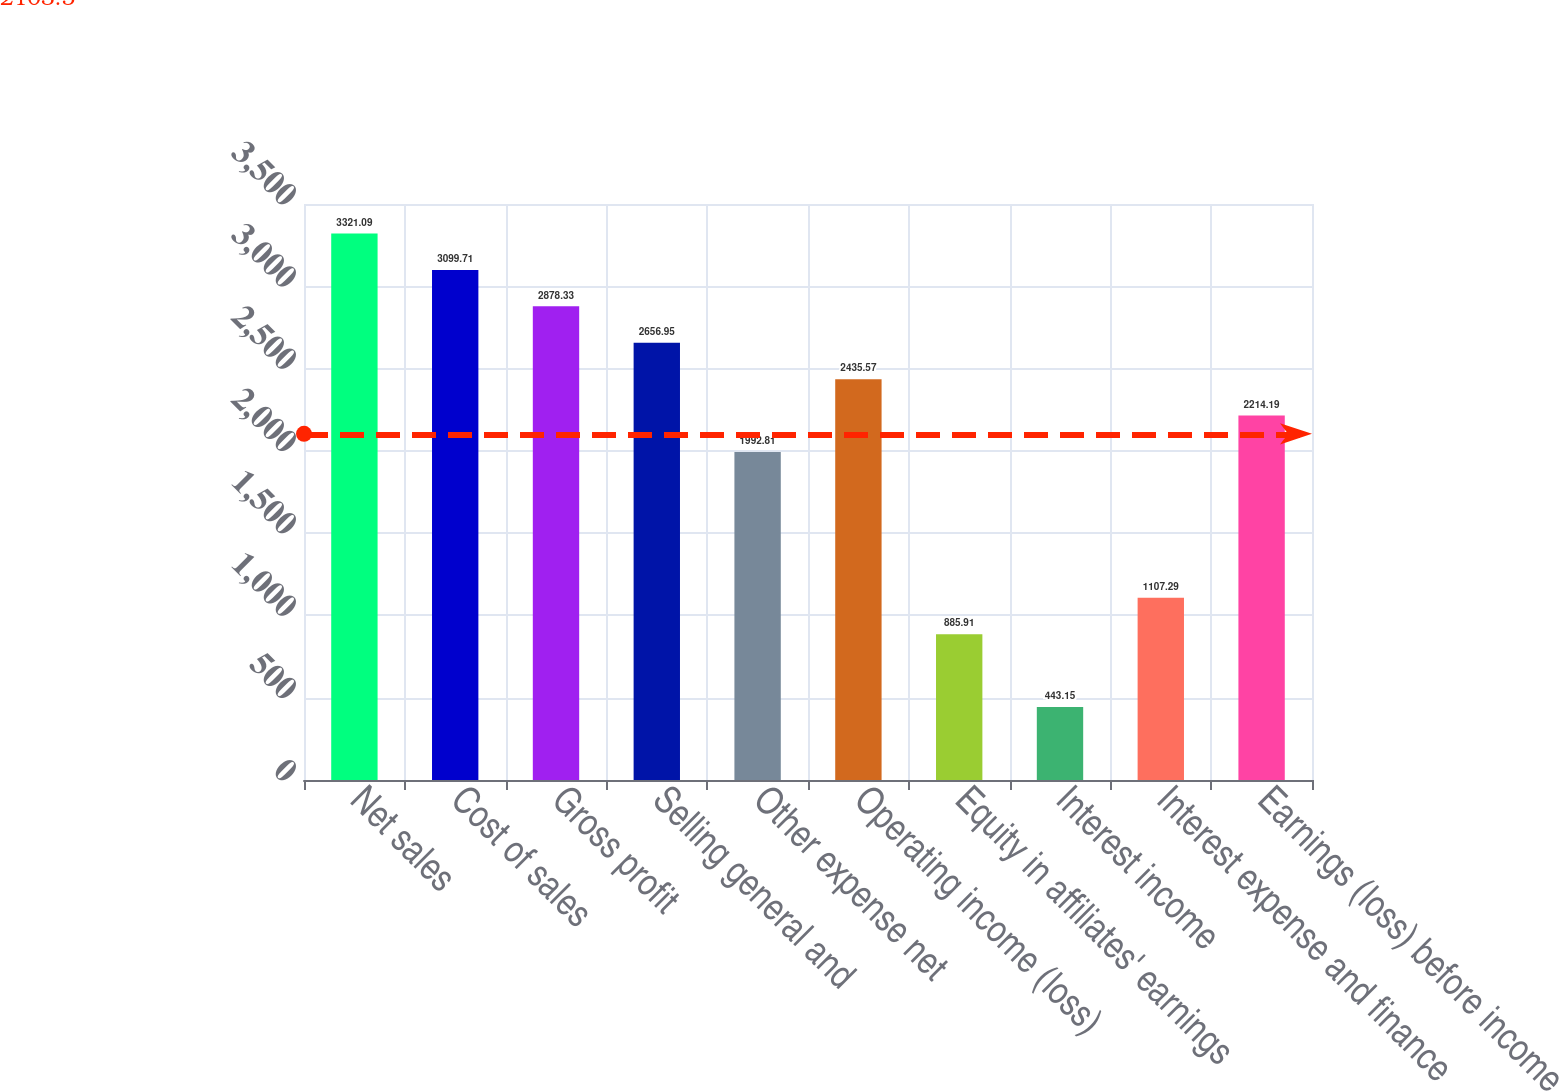<chart> <loc_0><loc_0><loc_500><loc_500><bar_chart><fcel>Net sales<fcel>Cost of sales<fcel>Gross profit<fcel>Selling general and<fcel>Other expense net<fcel>Operating income (loss)<fcel>Equity in affiliates' earnings<fcel>Interest income<fcel>Interest expense and finance<fcel>Earnings (loss) before income<nl><fcel>3321.09<fcel>3099.71<fcel>2878.33<fcel>2656.95<fcel>1992.81<fcel>2435.57<fcel>885.91<fcel>443.15<fcel>1107.29<fcel>2214.19<nl></chart> 